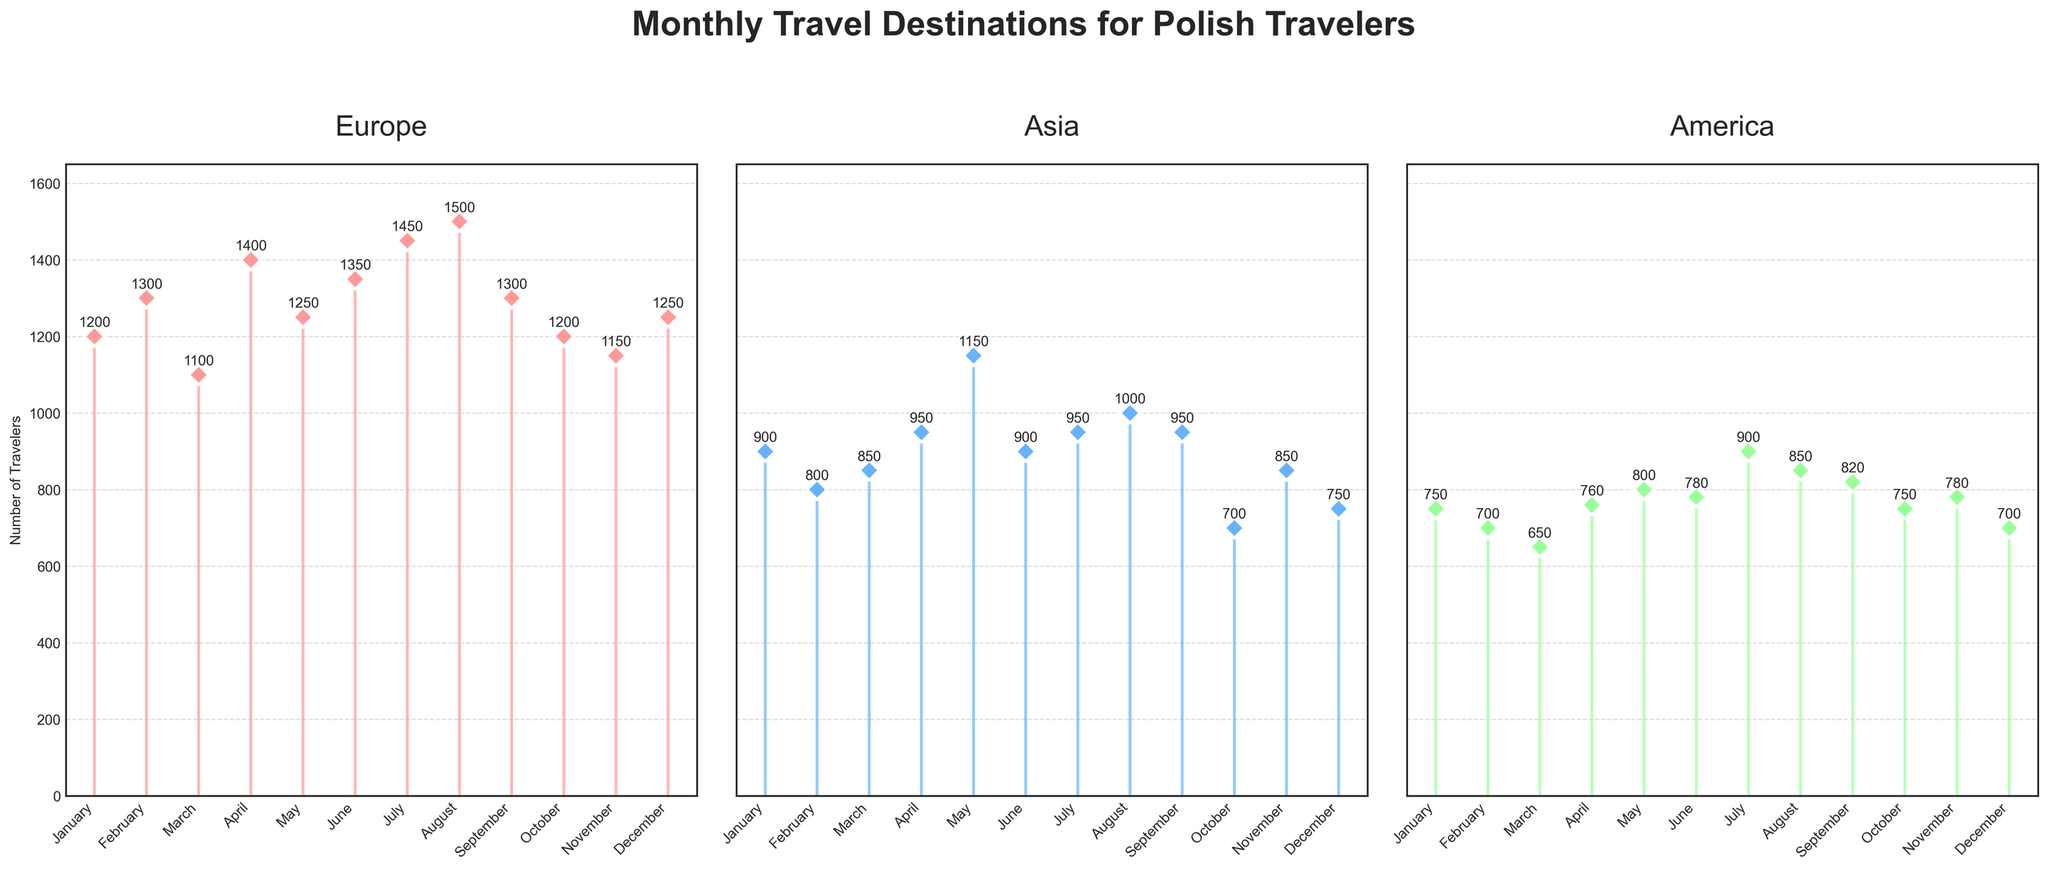Which month had the highest number of travelers going to Europe? The subplot for Europe shows a peak in August with 1500 travelers, which is the highest value in that region.
Answer: August What is the average number of travelers to Asian destinations over the months? Sum the number of travelers to Asian destinations and divide by the number of months: (900 + 800 + 850 + 950 + 1150 + 900 + 950 + 1000 + 950 + 700 + 850 + 750) / 12 = 10200 / 12 = 850.
Answer: 850 Which region had the highest number of travelers in July? By observing the three subplots for July, Europe (Amsterdam) had 1450 travelers, Asia (Kyoto) had 950 travelers, and America (Las Vegas) had 900 travelers. Europe had the highest number.
Answer: Europe Which month had the least number of travelers to America? From the subplot for America, the month with the lowest value is March (Miami) with 650 travelers.
Answer: March What's the difference in the number of travelers to Asian destinations between May and October? The number of travelers in May to Dubai is 1150 and in October to Jakarta is 700. The difference is 1150 - 700 = 450.
Answer: 450 What is the total number of travelers to all regions in January? Sum the number of travelers to destinations in January: Europe (Paris) 1200 + Asia (Tokyo) 900 + America (New York) 750 = 2850.
Answer: 2850 Which destination in Europe had the most travelers in any given month? By checking each month in the Europe subplot, the highest value recorded is in August (Prague) with 1500 travelers.
Answer: Prague How did the number of travelers to America change from February to March? Number of travelers in February (Los Angeles) is 700 and in March (Miami) is 650. The change is 650 - 700 = -50, so a decrease of 50.
Answer: Decrease by 50 Which month had the closest number of travelers comparing Europe and America? By reviewing each month, in November Europe (Athens) had 1150 travelers and America (Boston) had 780 travelers. The difference (1150 - 780 = 370) is the smallest compared to other months.
Answer: November What is the median number of travelers to American destinations? Arrange the numbers from America subplot: [650, 700, 700, 750, 760, 780, 780, 800, 820, 850, 900, 900]. The median is the average of the 6th and 7th numbers (780 and 780), so the median is (780 + 780) / 2 = 780.
Answer: 780 